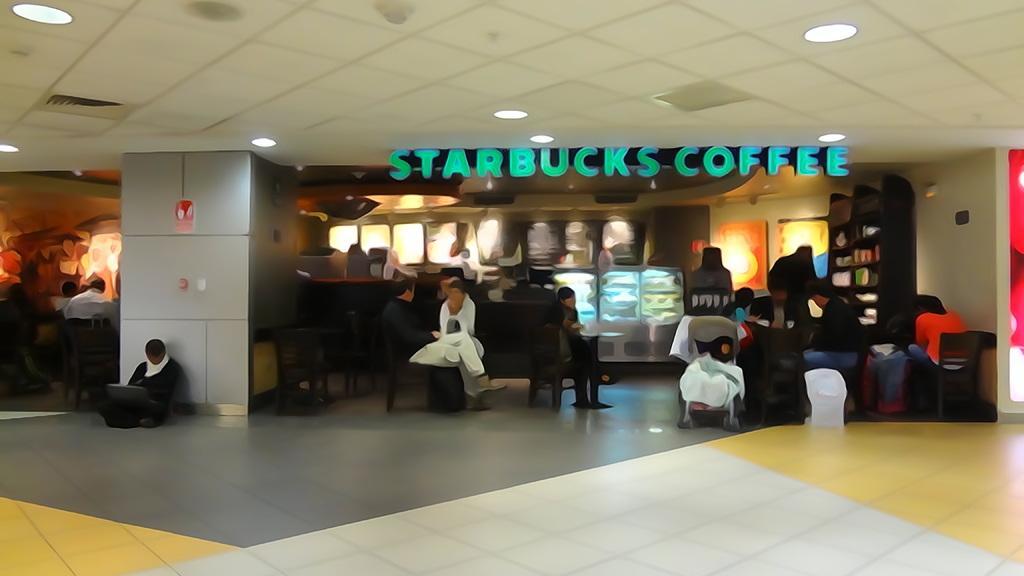In one or two sentences, can you explain what this image depicts? It is an edited picture. In this picture, few people. Few are sitting on the chairs and floor. Here we can see few objects, pillar, wall, floor and some text. Top of the image, there is a ceiling and lights. 